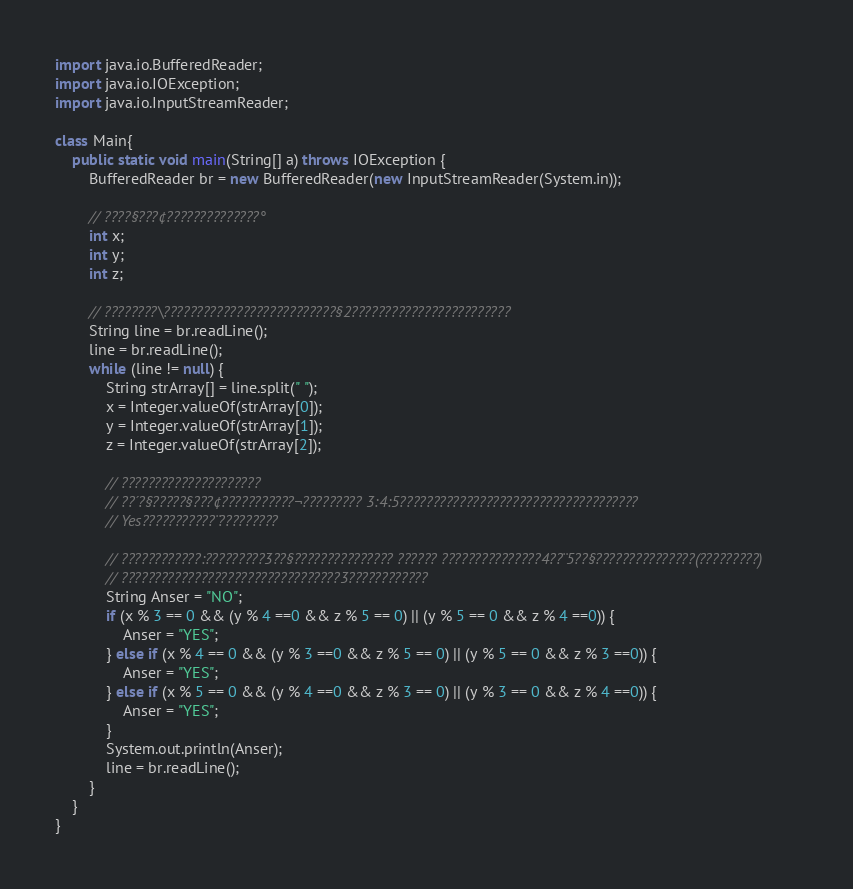Convert code to text. <code><loc_0><loc_0><loc_500><loc_500><_Java_>import java.io.BufferedReader;
import java.io.IOException;
import java.io.InputStreamReader;

class Main{
    public static void main(String[] a) throws IOException {
		BufferedReader br = new BufferedReader(new InputStreamReader(System.in));

		// ????§???¢??????????????°
		int x;
		int y;
		int z;

		// ????????\??????????????????????????§2????????????????????????
		String line = br.readLine();
		line = br.readLine();
		while (line != null) {
			String strArray[] = line.split(" ");
			x = Integer.valueOf(strArray[0]);
			y = Integer.valueOf(strArray[1]);
			z = Integer.valueOf(strArray[2]);

			// ?????????????????????
			// ??´?§?????§???¢???????????¬????????? 3:4:5????????????????????????????????????
			// Yes???????????¨?????????

			// ????????????:?????????3??§??????????????? ?????? ???????????????4??¨5??§???????????????(?????????)
			// ?????????????????????????????????3????????????
			String Anser = "NO";
			if (x % 3 == 0 && (y % 4 ==0 && z % 5 == 0) || (y % 5 == 0 && z % 4 ==0)) {
				Anser = "YES";
			} else if (x % 4 == 0 && (y % 3 ==0 && z % 5 == 0) || (y % 5 == 0 && z % 3 ==0)) {
				Anser = "YES";
			} else if (x % 5 == 0 && (y % 4 ==0 && z % 3 == 0) || (y % 3 == 0 && z % 4 ==0)) {
				Anser = "YES";
			}
			System.out.println(Anser);
			line = br.readLine();
		}
    }
}</code> 